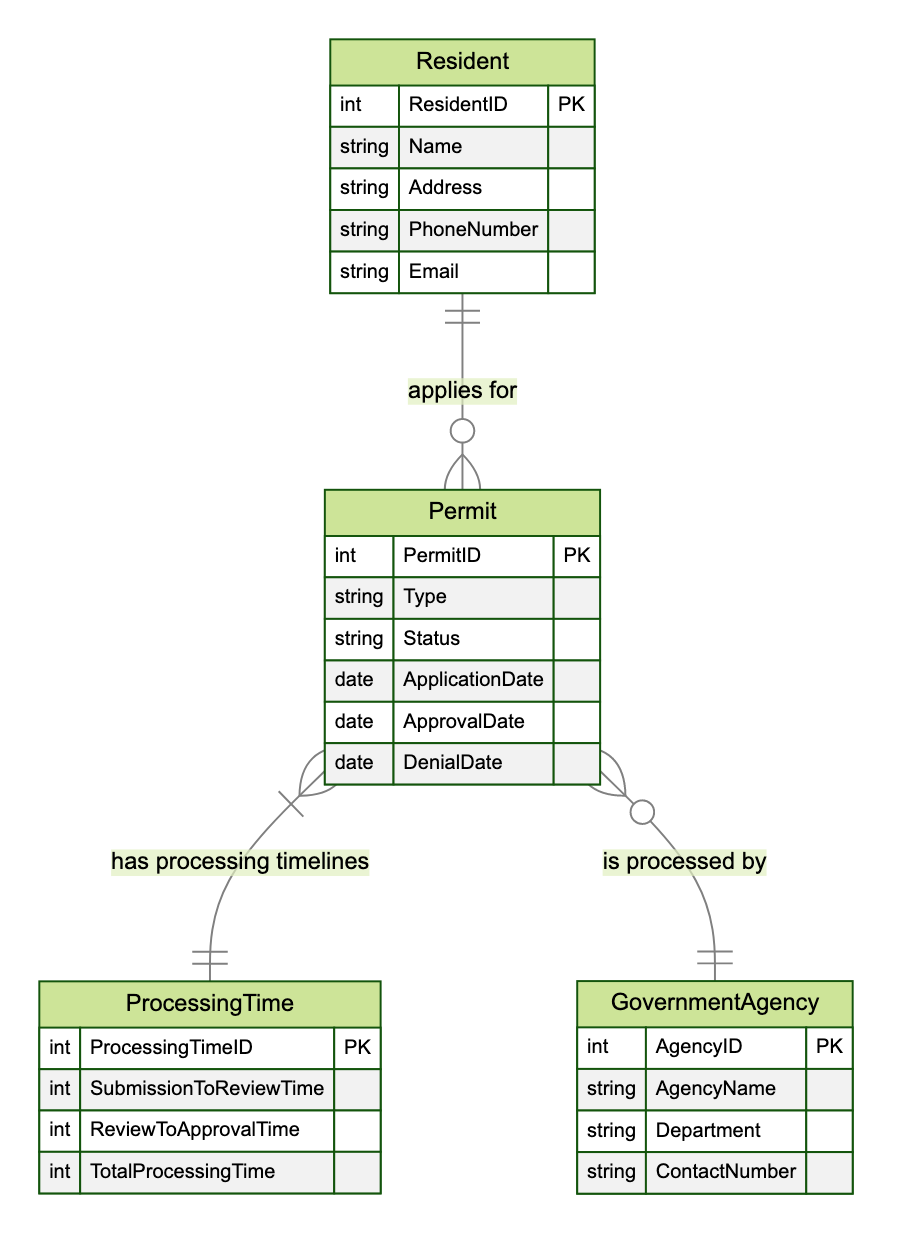What is the primary relationship between Resident and Permit? The primary relationship is defined in the diagram as "applies for," indicating that a resident can apply for multiple permits. This is denoted by the cardinality "1 to many."
Answer: applies for How many attributes does the Permit entity have? The Permit entity is listed with five attributes: PermitID, Type, Status, ApplicationDate, and ApprovalDate. Counting these gives a total of five attributes.
Answer: 5 What is the cardinality between Permit and Government Agency? The cardinality between Permit and Government Agency is "many to 1," meaning that multiple permits can be processed by a single government agency but each permit is processed by only one agency.
Answer: many to 1 What are the attributes of the ProcessingTime entity? The ProcessingTime entity contains four attributes: ProcessingTimeID, SubmissionToReviewTime, ReviewToApprovalTime, and TotalProcessingTime. Listing these attributes gives us a clear view of what data is stored in this entity.
Answer: ProcessingTimeID, SubmissionToReviewTime, ReviewToApprovalTime, TotalProcessingTime Which entity is processed by Government Agency? The Permit entity is processed by the Government Agency, as indicated by the line connecting these two entities, along with the relationship "is processed by." The diagram illustrates that permits require processing by government agencies.
Answer: Permit What is the main purpose of the ProcessingTime entity in this diagram? The main purpose of the ProcessingTime entity is to hold the processing timelines associated with permits. The diagram shows that each permit has corresponding processing timelines, linking it through the relationship "has processing timelines."
Answer: hold processing timelines Which entity has the status attribute? The Permit entity contains the status attribute, which is used to track the current state of the permit application process. The relationship lines and attribute listings in the diagram indicate where this attribute is located.
Answer: Permit What type of relationship does ProcessingTime have with Permit? ProcessingTime has a "1 to 1" relationship with Permit. This indicates that each permit has exactly one corresponding processing time record. The diagram explicitly states this relationship and its cardinality.
Answer: 1 to 1 How many entities are shown in this diagram? The diagram displays four entities: Resident, Permit, GovernmentAgency, and ProcessingTime. Counting each uniquely listed entity provides the total count.
Answer: 4 